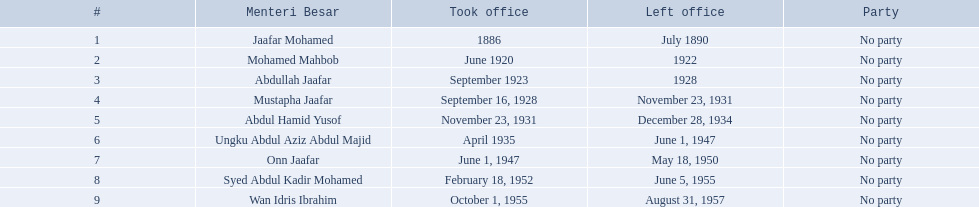Who are all of the menteri besars? Jaafar Mohamed, Mohamed Mahbob, Abdullah Jaafar, Mustapha Jaafar, Abdul Hamid Yusof, Ungku Abdul Aziz Abdul Majid, Onn Jaafar, Syed Abdul Kadir Mohamed, Wan Idris Ibrahim. When did each take office? 1886, June 1920, September 1923, September 16, 1928, November 23, 1931, April 1935, June 1, 1947, February 18, 1952, October 1, 1955. When did they leave? July 1890, 1922, 1928, November 23, 1931, December 28, 1934, June 1, 1947, May 18, 1950, June 5, 1955, August 31, 1957. And which spent the most time in office? Ungku Abdul Aziz Abdul Majid. 